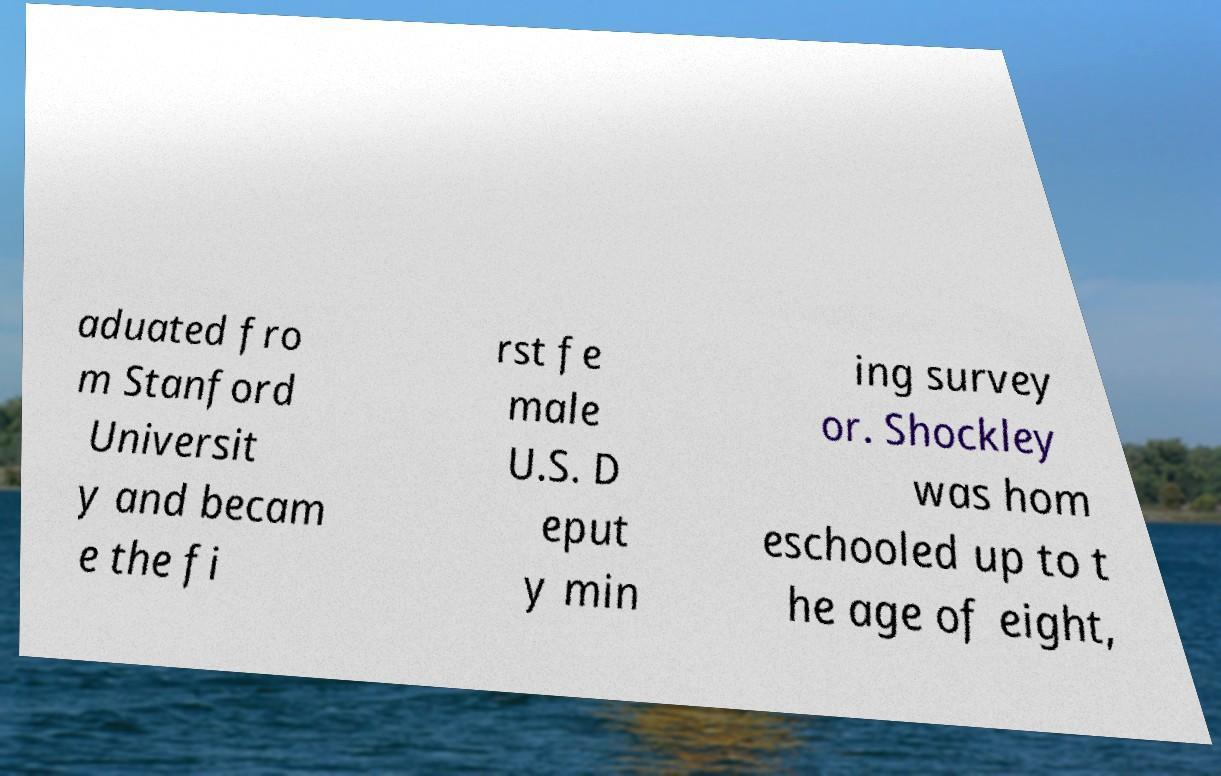Please read and relay the text visible in this image. What does it say? aduated fro m Stanford Universit y and becam e the fi rst fe male U.S. D eput y min ing survey or. Shockley was hom eschooled up to t he age of eight, 